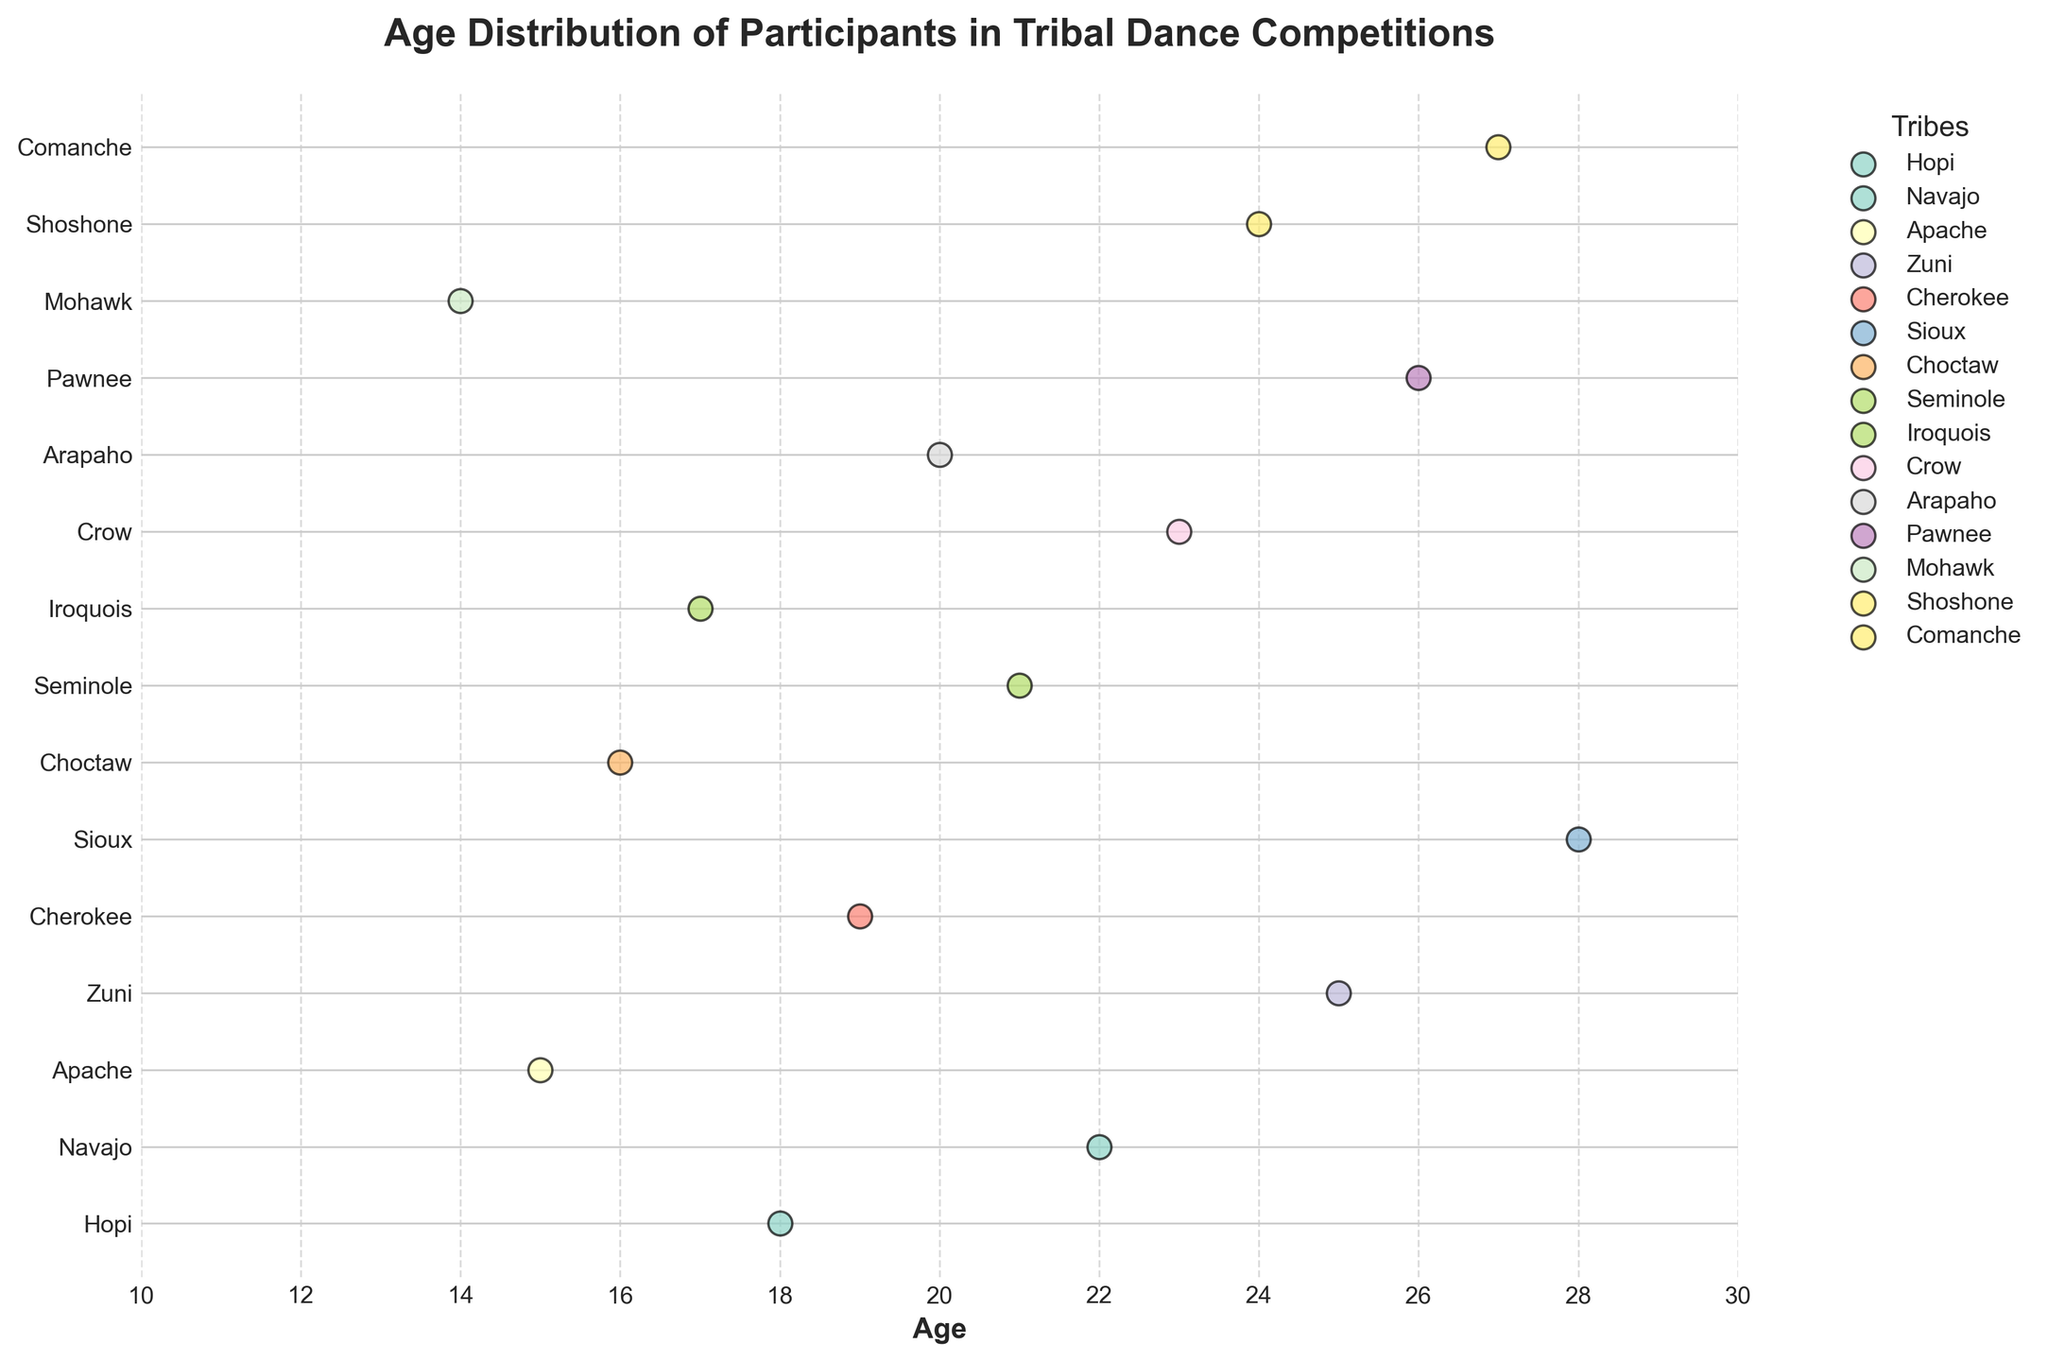What's the title of the plot? The title is the text at the top of the plot. This provides context for what the visual representation is about.
Answer: Age Distribution of Participants in Tribal Dance Competitions How many tribes are represented in the plot? Count the number of unique tribe labels on the y-axis. Each tribe label corresponds to a unique tribe.
Answer: 15 What is the age range of participants from the Sioux tribe? Locate the Sioux tribe on the y-axis and then identify the ages of participants (dot positions) in that row. There is only one dot for Sioux.
Answer: 28 Which tribe has the youngest participant, and what is their age? Identify the position of the lowest dot on the age axis and check its corresponding tribe on the y-axis.
Answer: Mohawk, age 14 What is the distribution of ages for the Cherokee tribe? Locate the Cherokee tribe on the y-axis and observe the dots representing their ages. There is only one dot for Cherokee.
Answer: Age 19 Are there any tribes with participants only above the age of 25? If so, list them. Look for tribes on the y-axis where all dots are situated above the age 25 line on the x-axis. Only consider tribes with dots exclusively above 25.
Answer: Comanche What is the average age of participants from the Apache tribe? Locate the Apache tribe on the y-axis and identify the ages of participants (dot positions). Calculate the average of these ages. There is only one dot for Apache. 15
Answer: 15 Which tribe has participants both above and below the age of 20? Observe the data points for each tribe and identify any tribe whose dots fall on both sides of the age 20 vertical line.
Answer: Hopi How many participants are there from the Hopi tribe? Count the number of dots in the row corresponding to the Hopi tribe.
Answer: 1 Which tribes have exactly one participant each? Identify rows (tribes) that have only one dot. Black borders around each dot might help in counting them clearly.
Answer: All tribes 